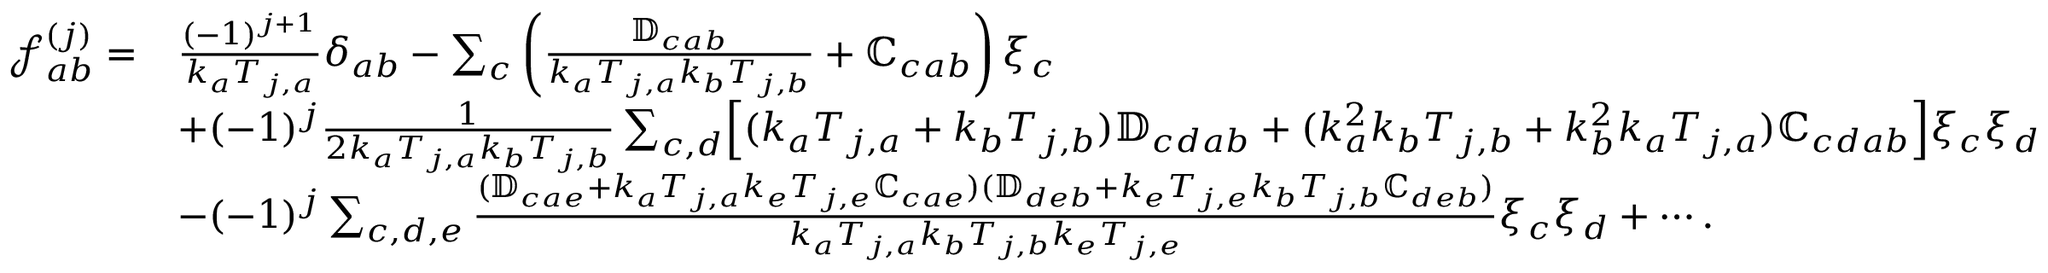Convert formula to latex. <formula><loc_0><loc_0><loc_500><loc_500>\begin{array} { r l } { \mathcal { f } _ { a b } ^ { ( j ) } = } & { \frac { ( - 1 ) ^ { j + 1 } } { k _ { a } T _ { j , a } } \delta _ { a b } - \sum _ { c } \left ( \frac { \mathbb { D } _ { c a b } } { k _ { a } T _ { j , a } k _ { b } T _ { j , b } } + \mathbb { C } _ { c a b } \right ) \xi _ { c } } \\ & { + ( - 1 ) ^ { j } \frac { 1 } { 2 k _ { a } T _ { j , a } k _ { b } T _ { j , b } } \sum _ { c , d } \left [ ( k _ { a } T _ { j , a } + k _ { b } T _ { j , b } ) \mathbb { D } _ { c d a b } + ( k _ { a } ^ { 2 } k _ { b } T _ { j , b } + k _ { b } ^ { 2 } k _ { a } T _ { j , a } ) \mathbb { C } _ { c d a b } \right ] \xi _ { c } \xi _ { d } } \\ & { - ( - 1 ) ^ { j } \sum _ { c , d , e } \frac { ( \mathbb { D } _ { c a e } + k _ { a } T _ { j , a } k _ { e } T _ { j , e } \mathbb { C } _ { c a e } ) ( \mathbb { D } _ { d e b } + k _ { e } T _ { j , e } k _ { b } T _ { j , b } \mathbb { C } _ { d e b } ) } { k _ { a } T _ { j , a } k _ { b } T _ { j , b } k _ { e } T _ { j , e } } \xi _ { c } \xi _ { d } + \cdots . } \end{array}</formula> 